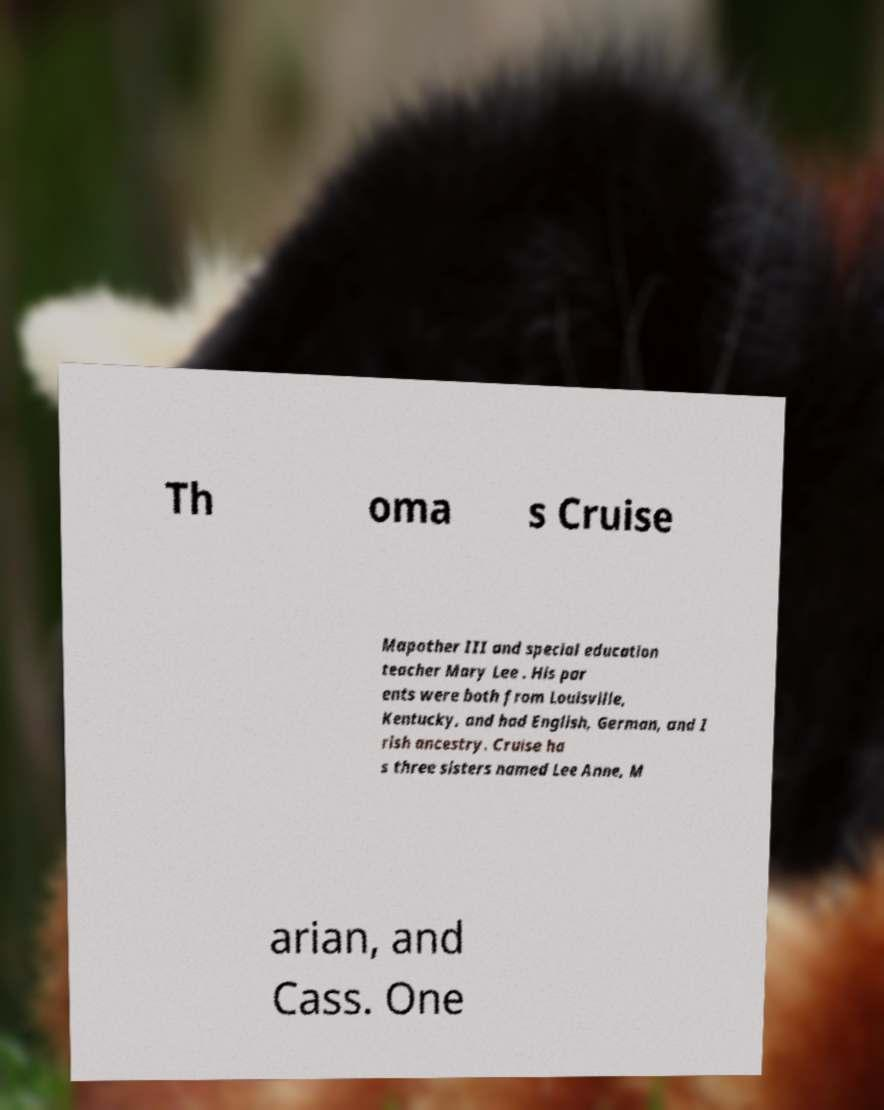For documentation purposes, I need the text within this image transcribed. Could you provide that? Th oma s Cruise Mapother III and special education teacher Mary Lee . His par ents were both from Louisville, Kentucky, and had English, German, and I rish ancestry. Cruise ha s three sisters named Lee Anne, M arian, and Cass. One 